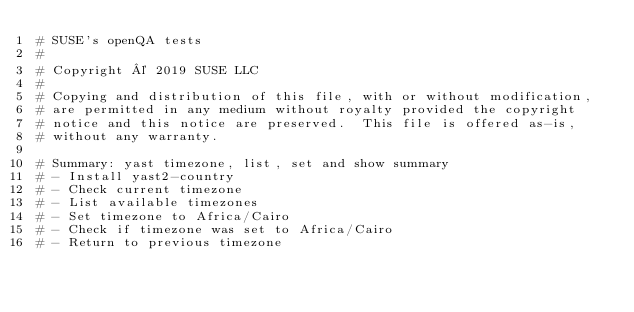<code> <loc_0><loc_0><loc_500><loc_500><_Perl_># SUSE's openQA tests
#
# Copyright © 2019 SUSE LLC
#
# Copying and distribution of this file, with or without modification,
# are permitted in any medium without royalty provided the copyright
# notice and this notice are preserved.  This file is offered as-is,
# without any warranty.

# Summary: yast timezone, list, set and show summary
# - Install yast2-country
# - Check current timezone
# - List available timezones
# - Set timezone to Africa/Cairo
# - Check if timezone was set to Africa/Cairo
# - Return to previous timezone</code> 